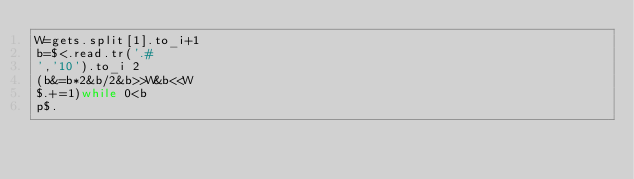<code> <loc_0><loc_0><loc_500><loc_500><_Ruby_>W=gets.split[1].to_i+1
b=$<.read.tr('.#
','10').to_i 2
(b&=b*2&b/2&b>>W&b<<W
$.+=1)while 0<b
p$.</code> 